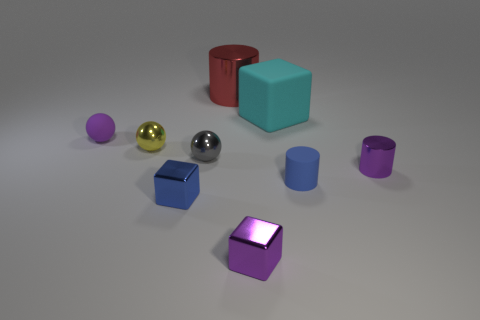The yellow ball that is made of the same material as the red cylinder is what size?
Provide a short and direct response. Small. There is a object that is both to the left of the small purple block and in front of the small metal cylinder; what is its color?
Keep it short and to the point. Blue. There is a tiny rubber thing on the left side of the tiny yellow thing; is it the same shape as the metal object that is behind the large cyan block?
Your response must be concise. No. There is a small blue object that is in front of the blue cylinder; what material is it?
Your response must be concise. Metal. There is a shiny cylinder that is the same color as the tiny rubber ball; what is its size?
Your answer should be compact. Small. How many objects are either tiny objects to the left of the red metallic object or small purple cylinders?
Keep it short and to the point. 5. Are there an equal number of big cyan blocks that are in front of the small matte cylinder and large brown rubber cubes?
Make the answer very short. Yes. Does the matte sphere have the same size as the rubber cylinder?
Provide a short and direct response. Yes. There is a matte ball that is the same size as the blue rubber thing; what is its color?
Make the answer very short. Purple. There is a gray ball; is its size the same as the metallic cylinder in front of the small purple ball?
Offer a very short reply. Yes. 